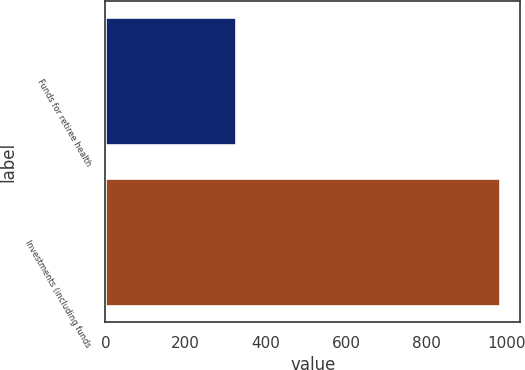<chart> <loc_0><loc_0><loc_500><loc_500><bar_chart><fcel>Funds for retiree health<fcel>Investments (including funds<nl><fcel>325<fcel>985<nl></chart> 